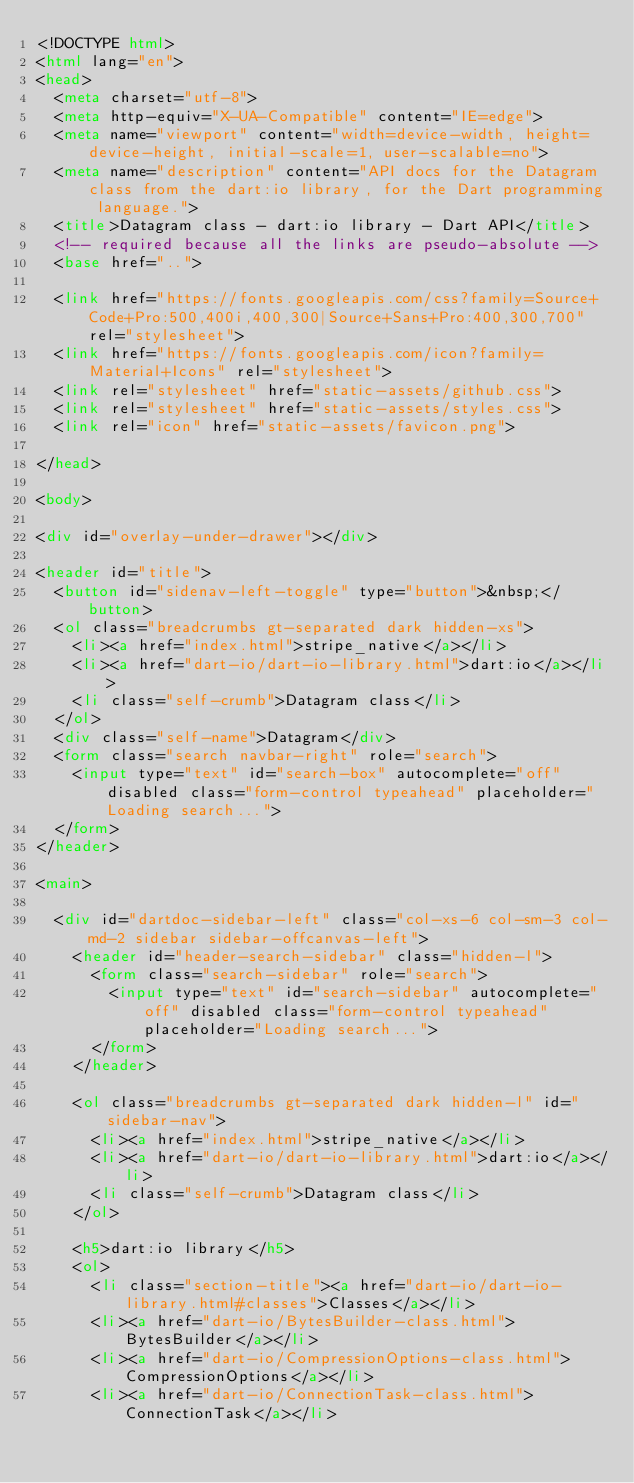<code> <loc_0><loc_0><loc_500><loc_500><_HTML_><!DOCTYPE html>
<html lang="en">
<head>
  <meta charset="utf-8">
  <meta http-equiv="X-UA-Compatible" content="IE=edge">
  <meta name="viewport" content="width=device-width, height=device-height, initial-scale=1, user-scalable=no">
  <meta name="description" content="API docs for the Datagram class from the dart:io library, for the Dart programming language.">
  <title>Datagram class - dart:io library - Dart API</title>
  <!-- required because all the links are pseudo-absolute -->
  <base href="..">

  <link href="https://fonts.googleapis.com/css?family=Source+Code+Pro:500,400i,400,300|Source+Sans+Pro:400,300,700" rel="stylesheet">
  <link href="https://fonts.googleapis.com/icon?family=Material+Icons" rel="stylesheet">
  <link rel="stylesheet" href="static-assets/github.css">
  <link rel="stylesheet" href="static-assets/styles.css">
  <link rel="icon" href="static-assets/favicon.png">
  
</head>

<body>

<div id="overlay-under-drawer"></div>

<header id="title">
  <button id="sidenav-left-toggle" type="button">&nbsp;</button>
  <ol class="breadcrumbs gt-separated dark hidden-xs">
    <li><a href="index.html">stripe_native</a></li>
    <li><a href="dart-io/dart-io-library.html">dart:io</a></li>
    <li class="self-crumb">Datagram class</li>
  </ol>
  <div class="self-name">Datagram</div>
  <form class="search navbar-right" role="search">
    <input type="text" id="search-box" autocomplete="off" disabled class="form-control typeahead" placeholder="Loading search...">
  </form>
</header>

<main>

  <div id="dartdoc-sidebar-left" class="col-xs-6 col-sm-3 col-md-2 sidebar sidebar-offcanvas-left">
    <header id="header-search-sidebar" class="hidden-l">
      <form class="search-sidebar" role="search">
        <input type="text" id="search-sidebar" autocomplete="off" disabled class="form-control typeahead" placeholder="Loading search...">
      </form>
    </header>
    
    <ol class="breadcrumbs gt-separated dark hidden-l" id="sidebar-nav">
      <li><a href="index.html">stripe_native</a></li>
      <li><a href="dart-io/dart-io-library.html">dart:io</a></li>
      <li class="self-crumb">Datagram class</li>
    </ol>
    
    <h5>dart:io library</h5>
    <ol>
      <li class="section-title"><a href="dart-io/dart-io-library.html#classes">Classes</a></li>
      <li><a href="dart-io/BytesBuilder-class.html">BytesBuilder</a></li>
      <li><a href="dart-io/CompressionOptions-class.html">CompressionOptions</a></li>
      <li><a href="dart-io/ConnectionTask-class.html">ConnectionTask</a></li></code> 